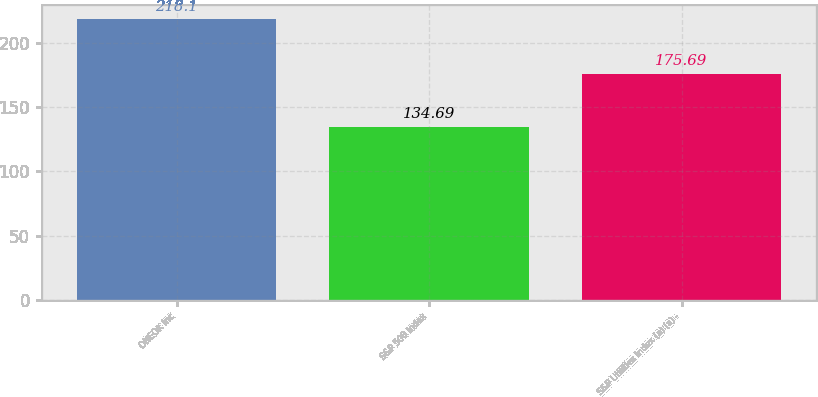Convert chart to OTSL. <chart><loc_0><loc_0><loc_500><loc_500><bar_chart><fcel>ONEOK Inc<fcel>S&P 500 Index<fcel>S&P Utilities Index (a) (a) -<nl><fcel>218.1<fcel>134.69<fcel>175.69<nl></chart> 